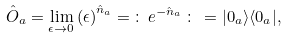<formula> <loc_0><loc_0><loc_500><loc_500>\hat { O } _ { a } = \lim _ { \epsilon \rightarrow 0 } \left ( \epsilon \right ) ^ { \hat { n } _ { a } } = \, \colon \, e ^ { - \hat { n } _ { a } } \, \colon \, = | 0 _ { a } \rangle \langle 0 _ { a } | ,</formula> 